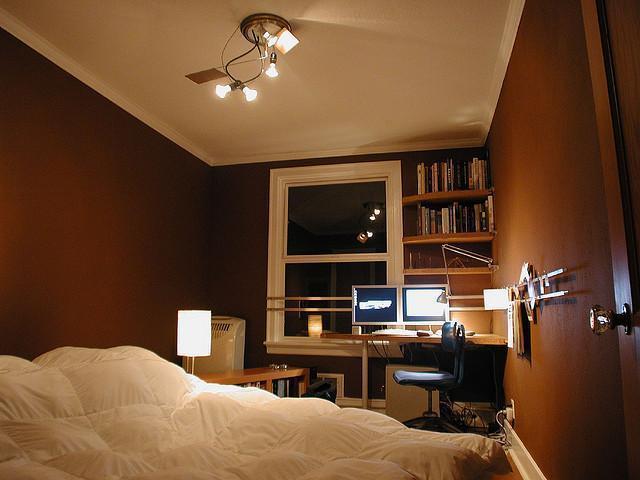How many bookshelves are there?
Give a very brief answer. 3. How many apple brand laptops can you see?
Give a very brief answer. 0. 